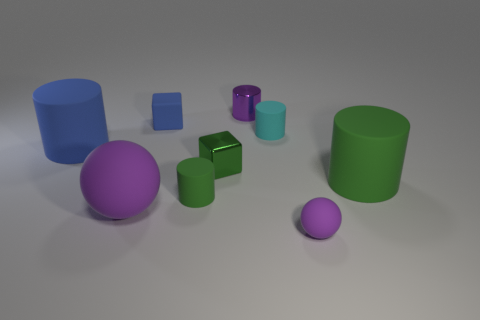Subtract all tiny shiny cylinders. How many cylinders are left? 4 Subtract all blue cylinders. How many cylinders are left? 4 Subtract all red cylinders. Subtract all gray cubes. How many cylinders are left? 5 Subtract 0 red balls. How many objects are left? 9 Subtract all cylinders. How many objects are left? 4 Subtract all tiny purple rubber cylinders. Subtract all tiny objects. How many objects are left? 3 Add 5 blue cubes. How many blue cubes are left? 6 Add 7 tiny blue rubber objects. How many tiny blue rubber objects exist? 8 